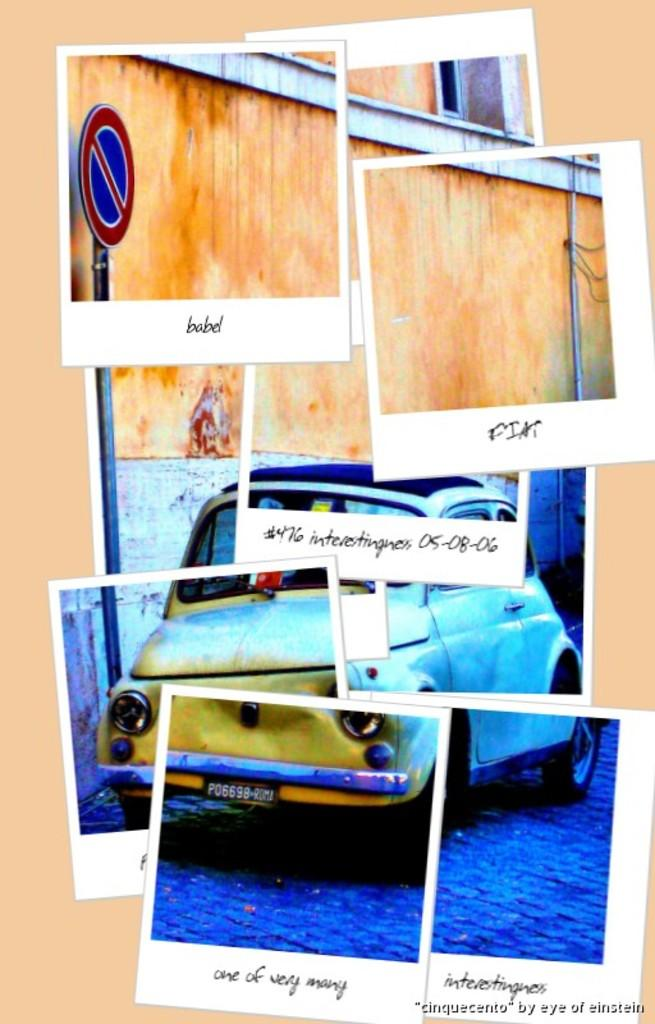What is the main subject of the image? The main subject of the image is a collage of pictures. Can you describe any specific pictures in the collage? Yes, the collage contains a picture of a car. What else can be seen in the collage besides the picture of the car? There is a sign board in the collage. What is visible behind the collage in the image? There is a wall visible behind the collage. Are there any writings or text on the pictures in the collage? Yes, there are writings on the pictures in the collage. What type of soda is being poured into the car in the image? There is no soda or pouring action depicted in the image; it features a collage of pictures with a car and a sign board. Is there any motion or movement happening in the image? The image does not depict any motion or movement; it is a still collage of pictures. 